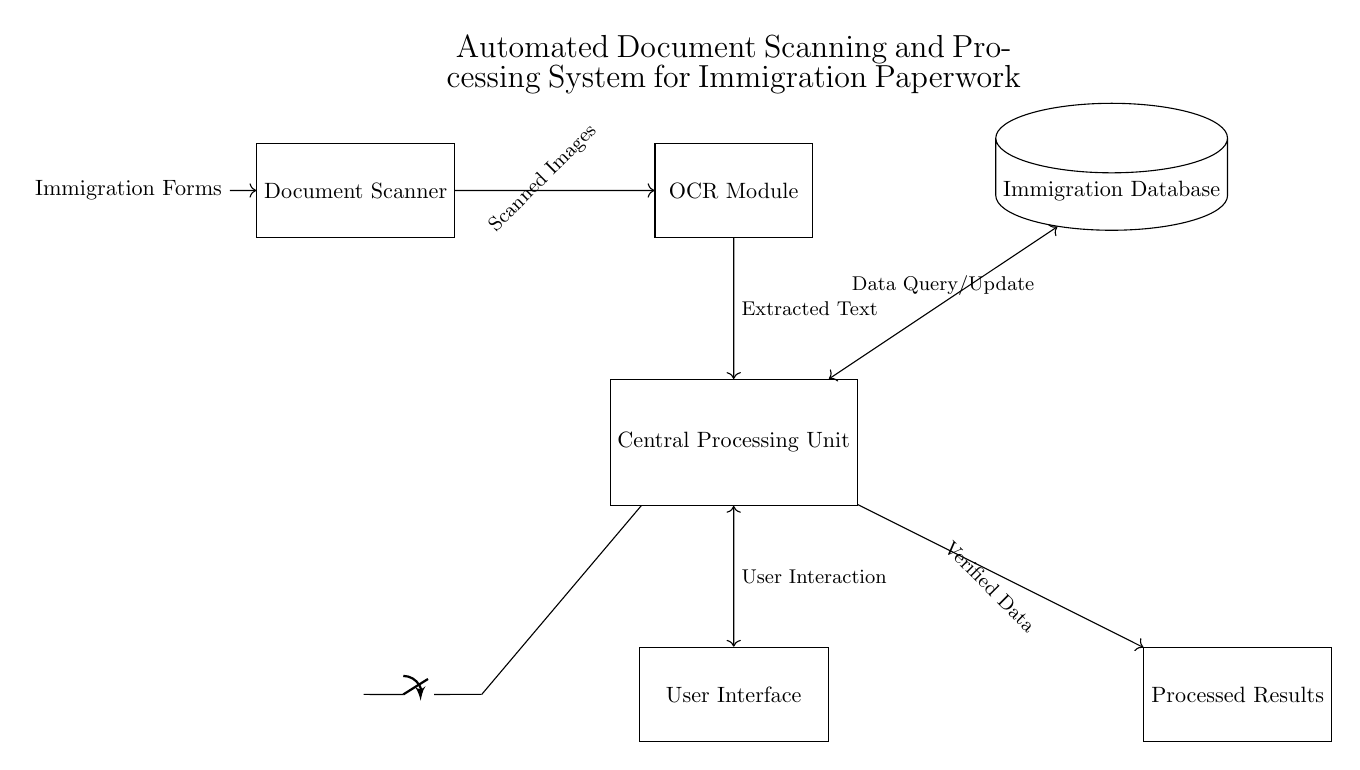What is the main component of this system? The main component is the Central Processing Unit, which handles data processing and control.
Answer: Central Processing Unit What type of module is used to interpret scanned text? The Optical Character Recognition module is specifically designed to convert scanned images of text into machine-readable text formats.
Answer: OCR Module How many main components are shown in the diagram? There are five main components: Document Scanner, OCR Module, Central Processing Unit, Immigration Database, and User Interface.
Answer: Five What connects the Document Scanner to the OCR Module? There is a direct connection that transmits scanned images from the Document Scanner to the OCR Module for text extraction.
Answer: Scanned Images What is the purpose of the connection between the CPU and the Database? The connection allows for data querying and updates between the CPU and the Immigration Database, ensuring that the processed immigration data can be stored and retrieved as needed.
Answer: Data Query/Update What is the role of the User Interface in this system? The User Interface allows for user interaction, enabling the user to input data and receive feedback from the system.
Answer: User Interaction What device supplies power to the system? The power supply is provided by a battery, which energizes the various components of the system for operation.
Answer: Battery 